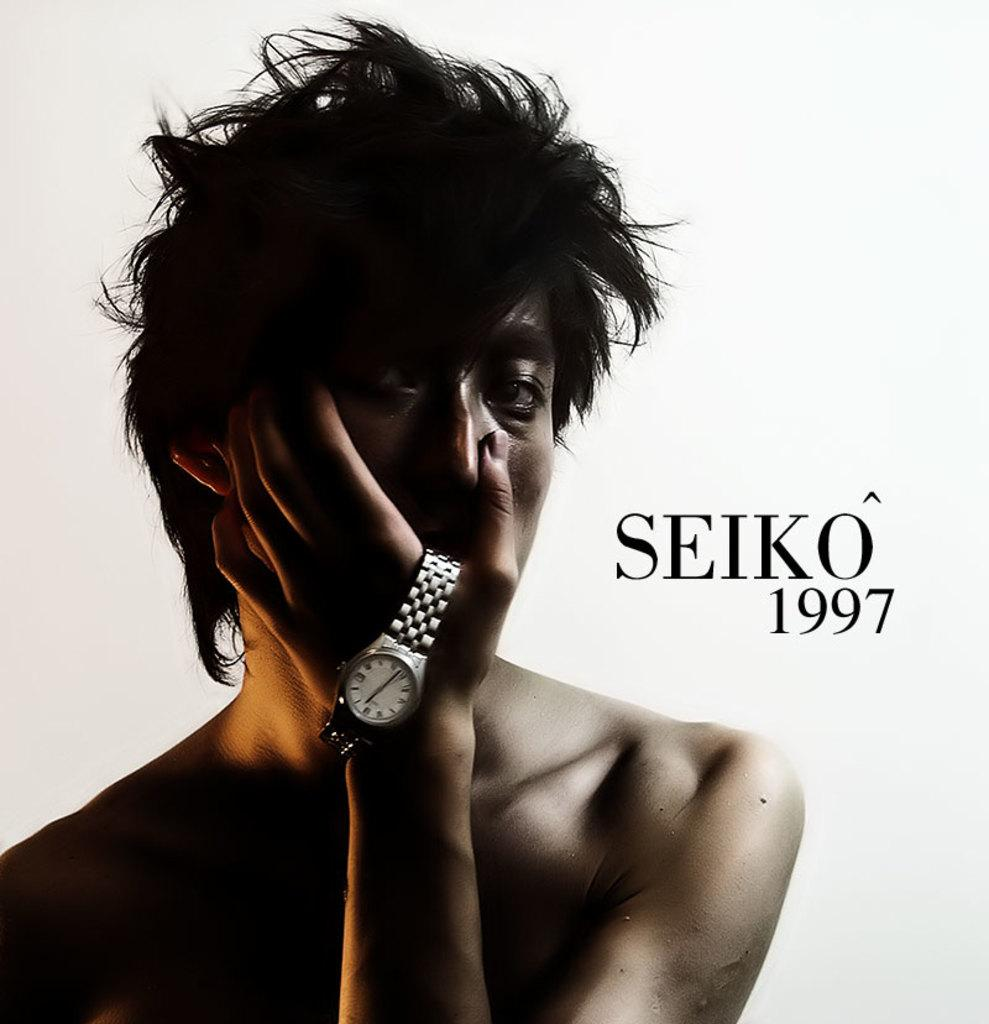What is the main subject of the image? There is a person in the image. Is there any text present in the image? Yes, there is text written on the image. What color is the background of the image? The background of the image is white. How many chairs are visible in the image? There are no chairs present in the image. What type of building can be seen in the background of the image? There is no building visible in the image, as the background is white. 